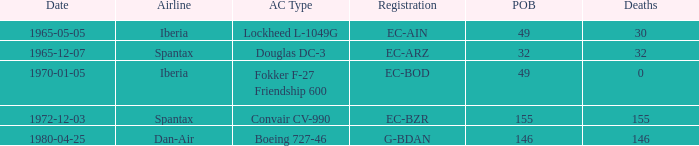How many fatalities are there for the airline of spantax, with a registration of ec-arz? 32.0. 